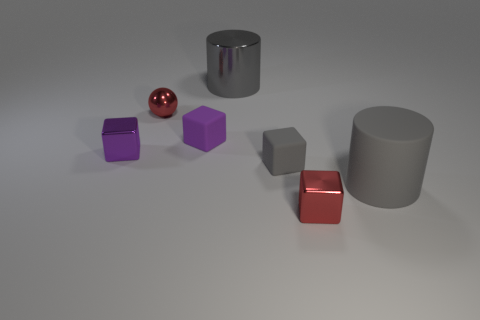There is a metallic thing that is both behind the large rubber cylinder and on the right side of the red sphere; what color is it?
Offer a very short reply. Gray. How many purple metal objects have the same size as the red ball?
Provide a short and direct response. 1. The red thing that is on the right side of the gray cylinder that is left of the red metallic block is what shape?
Provide a succinct answer. Cube. There is a shiny object on the left side of the red thing that is behind the large gray cylinder that is in front of the purple matte cube; what shape is it?
Provide a succinct answer. Cube. How many other big things have the same shape as the gray metal object?
Ensure brevity in your answer.  1. There is a small purple thing to the left of the sphere; what number of red metallic objects are in front of it?
Offer a terse response. 1. How many rubber objects are large things or tiny spheres?
Provide a succinct answer. 1. Are there any tiny purple objects made of the same material as the ball?
Make the answer very short. Yes. What number of things are either small red things that are on the left side of the shiny cylinder or small objects in front of the gray block?
Your answer should be very brief. 2. There is a small shiny object that is in front of the gray matte cylinder; is its color the same as the small metallic sphere?
Keep it short and to the point. Yes. 